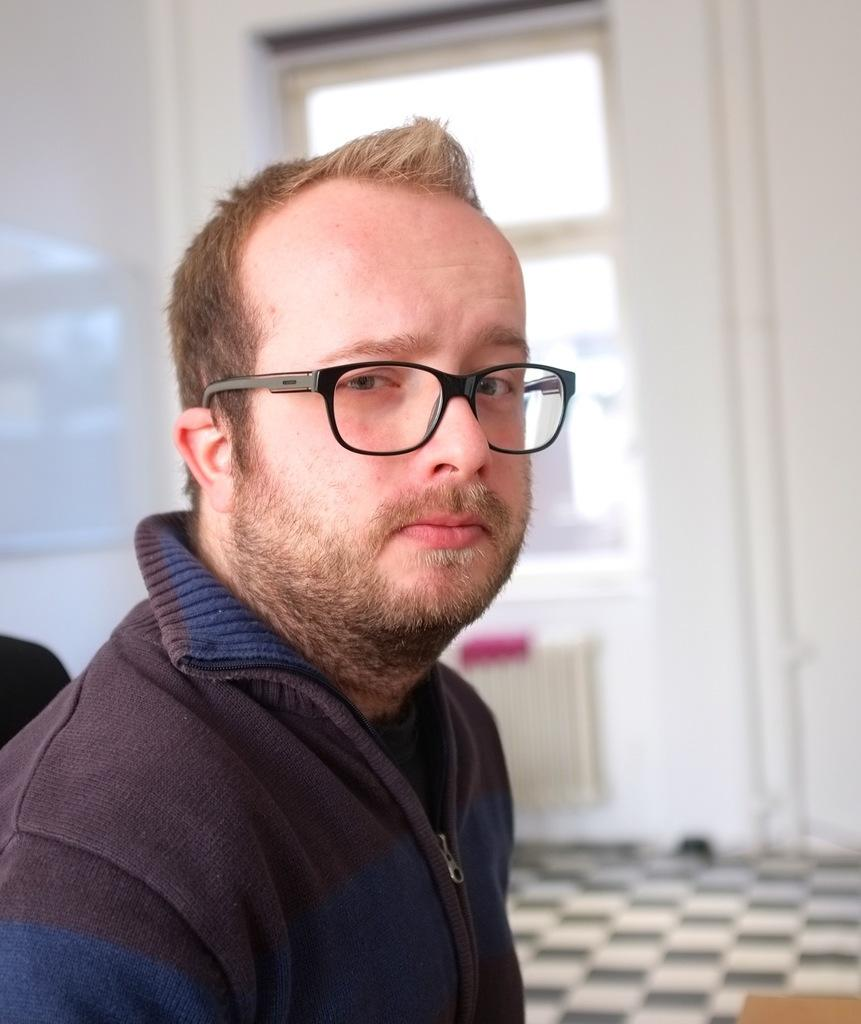What is located on the left side of the image? There is a man on the left side of the image. What is the man wearing? The man is wearing a jacket and spectacles. What is the man doing in the image? The man is looking at a picture. What can be seen in the background of the image? There is a wall and a window in the background of the image. What part of the room is visible in the image? The floor is visible in the image. What type of flesh can be seen in the image? There is no flesh visible in the image; it features a man looking at a picture with a wall and a window in the background. 